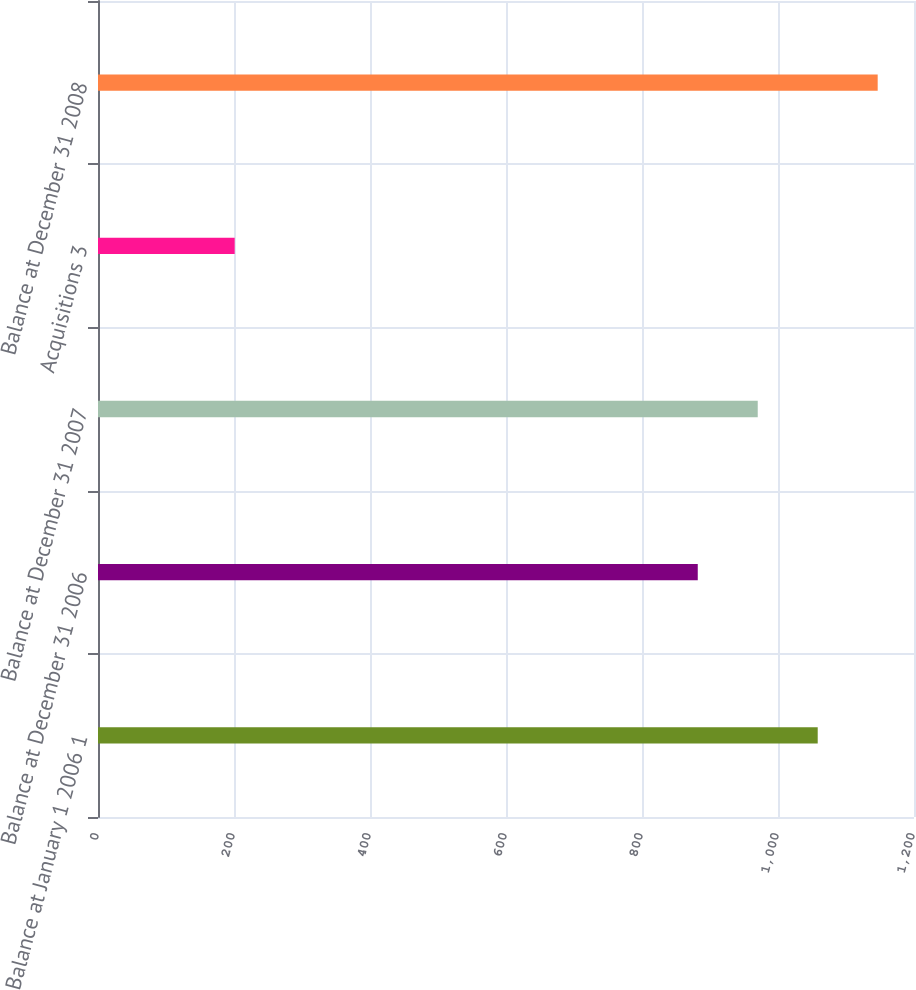Convert chart to OTSL. <chart><loc_0><loc_0><loc_500><loc_500><bar_chart><fcel>Balance at January 1 2006 1<fcel>Balance at December 31 2006<fcel>Balance at December 31 2007<fcel>Acquisitions 3<fcel>Balance at December 31 2008<nl><fcel>1058.4<fcel>882<fcel>970.2<fcel>201<fcel>1146.6<nl></chart> 